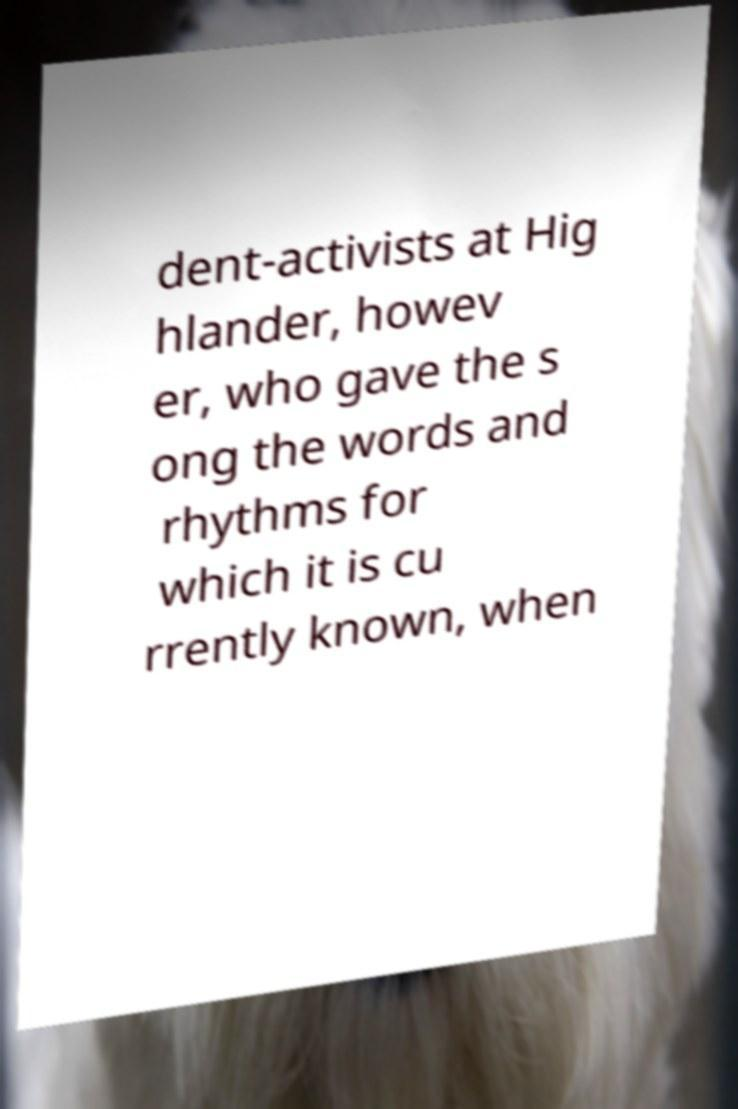I need the written content from this picture converted into text. Can you do that? dent-activists at Hig hlander, howev er, who gave the s ong the words and rhythms for which it is cu rrently known, when 